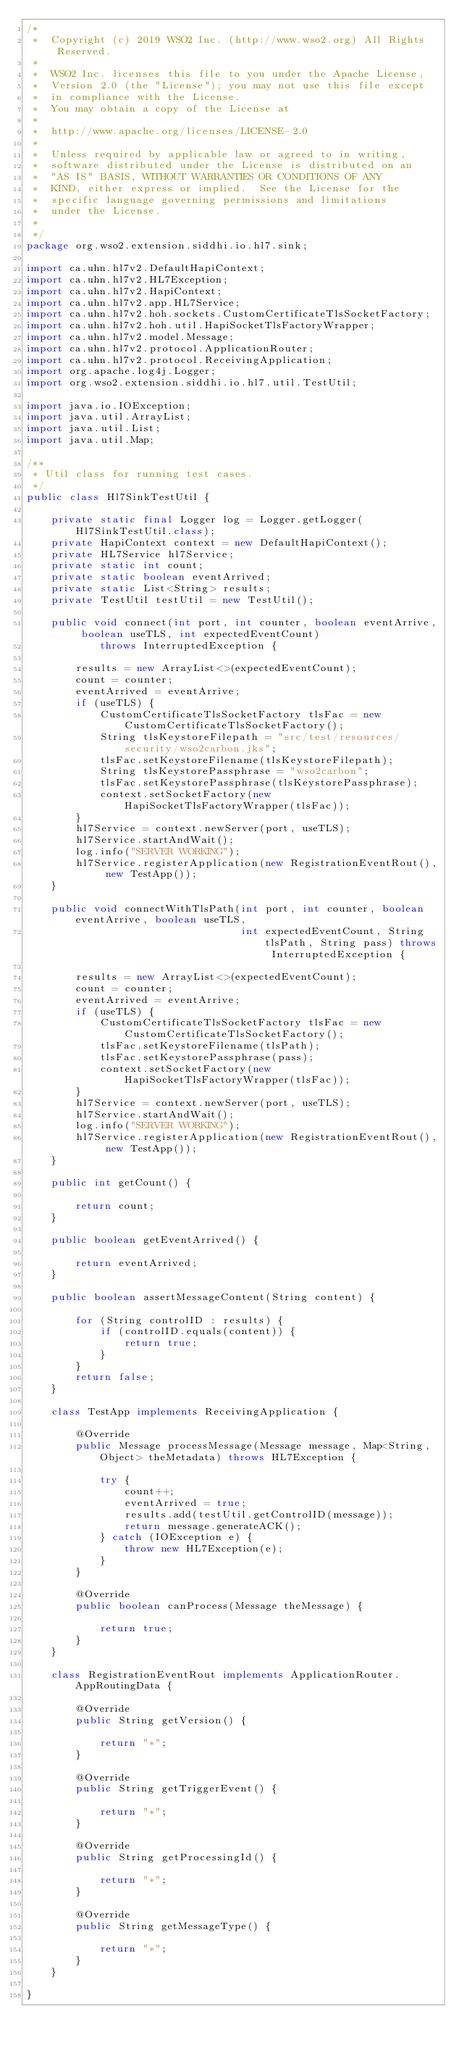Convert code to text. <code><loc_0><loc_0><loc_500><loc_500><_Java_>/*
 *  Copyright (c) 2019 WSO2 Inc. (http://www.wso2.org) All Rights Reserved.
 *
 *  WSO2 Inc. licenses this file to you under the Apache License,
 *  Version 2.0 (the "License"); you may not use this file except
 *  in compliance with the License.
 *  You may obtain a copy of the License at
 *
 *  http://www.apache.org/licenses/LICENSE-2.0
 *
 *  Unless required by applicable law or agreed to in writing,
 *  software distributed under the License is distributed on an
 *  "AS IS" BASIS, WITHOUT WARRANTIES OR CONDITIONS OF ANY
 *  KIND, either express or implied.  See the License for the
 *  specific language governing permissions and limitations
 *  under the License.
 *
 */
package org.wso2.extension.siddhi.io.hl7.sink;

import ca.uhn.hl7v2.DefaultHapiContext;
import ca.uhn.hl7v2.HL7Exception;
import ca.uhn.hl7v2.HapiContext;
import ca.uhn.hl7v2.app.HL7Service;
import ca.uhn.hl7v2.hoh.sockets.CustomCertificateTlsSocketFactory;
import ca.uhn.hl7v2.hoh.util.HapiSocketTlsFactoryWrapper;
import ca.uhn.hl7v2.model.Message;
import ca.uhn.hl7v2.protocol.ApplicationRouter;
import ca.uhn.hl7v2.protocol.ReceivingApplication;
import org.apache.log4j.Logger;
import org.wso2.extension.siddhi.io.hl7.util.TestUtil;

import java.io.IOException;
import java.util.ArrayList;
import java.util.List;
import java.util.Map;

/**
 * Util class for running test cases.
 */
public class Hl7SinkTestUtil {

    private static final Logger log = Logger.getLogger(Hl7SinkTestUtil.class);
    private HapiContext context = new DefaultHapiContext();
    private HL7Service hl7Service;
    private static int count;
    private static boolean eventArrived;
    private static List<String> results;
    private TestUtil testUtil = new TestUtil();

    public void connect(int port, int counter, boolean eventArrive, boolean useTLS, int expectedEventCount)
            throws InterruptedException {

        results = new ArrayList<>(expectedEventCount);
        count = counter;
        eventArrived = eventArrive;
        if (useTLS) {
            CustomCertificateTlsSocketFactory tlsFac = new CustomCertificateTlsSocketFactory();
            String tlsKeystoreFilepath = "src/test/resources/security/wso2carbon.jks";
            tlsFac.setKeystoreFilename(tlsKeystoreFilepath);
            String tlsKeystorePassphrase = "wso2carbon";
            tlsFac.setKeystorePassphrase(tlsKeystorePassphrase);
            context.setSocketFactory(new HapiSocketTlsFactoryWrapper(tlsFac));
        }
        hl7Service = context.newServer(port, useTLS);
        hl7Service.startAndWait();
        log.info("SERVER WORKING");
        hl7Service.registerApplication(new RegistrationEventRout(), new TestApp());
    }

    public void connectWithTlsPath(int port, int counter, boolean eventArrive, boolean useTLS,
                                   int expectedEventCount, String tlsPath, String pass) throws InterruptedException {

        results = new ArrayList<>(expectedEventCount);
        count = counter;
        eventArrived = eventArrive;
        if (useTLS) {
            CustomCertificateTlsSocketFactory tlsFac = new CustomCertificateTlsSocketFactory();
            tlsFac.setKeystoreFilename(tlsPath);
            tlsFac.setKeystorePassphrase(pass);
            context.setSocketFactory(new HapiSocketTlsFactoryWrapper(tlsFac));
        }
        hl7Service = context.newServer(port, useTLS);
        hl7Service.startAndWait();
        log.info("SERVER WORKING");
        hl7Service.registerApplication(new RegistrationEventRout(), new TestApp());
    }

    public int getCount() {

        return count;
    }

    public boolean getEventArrived() {

        return eventArrived;
    }

    public boolean assertMessageContent(String content) {

        for (String controlID : results) {
            if (controlID.equals(content)) {
                return true;
            }
        }
        return false;
    }

    class TestApp implements ReceivingApplication {

        @Override
        public Message processMessage(Message message, Map<String, Object> theMetadata) throws HL7Exception {

            try {
                count++;
                eventArrived = true;
                results.add(testUtil.getControlID(message));
                return message.generateACK();
            } catch (IOException e) {
                throw new HL7Exception(e);
            }
        }

        @Override
        public boolean canProcess(Message theMessage) {

            return true;
        }
    }

    class RegistrationEventRout implements ApplicationRouter.AppRoutingData {

        @Override
        public String getVersion() {

            return "*";
        }

        @Override
        public String getTriggerEvent() {

            return "*";
        }

        @Override
        public String getProcessingId() {

            return "*";
        }

        @Override
        public String getMessageType() {

            return "*";
        }
    }

}
</code> 